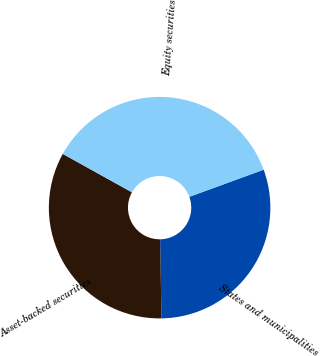Convert chart to OTSL. <chart><loc_0><loc_0><loc_500><loc_500><pie_chart><fcel>States and municipalities<fcel>Asset-backed securities<fcel>Equity securities<nl><fcel>30.3%<fcel>33.33%<fcel>36.36%<nl></chart> 